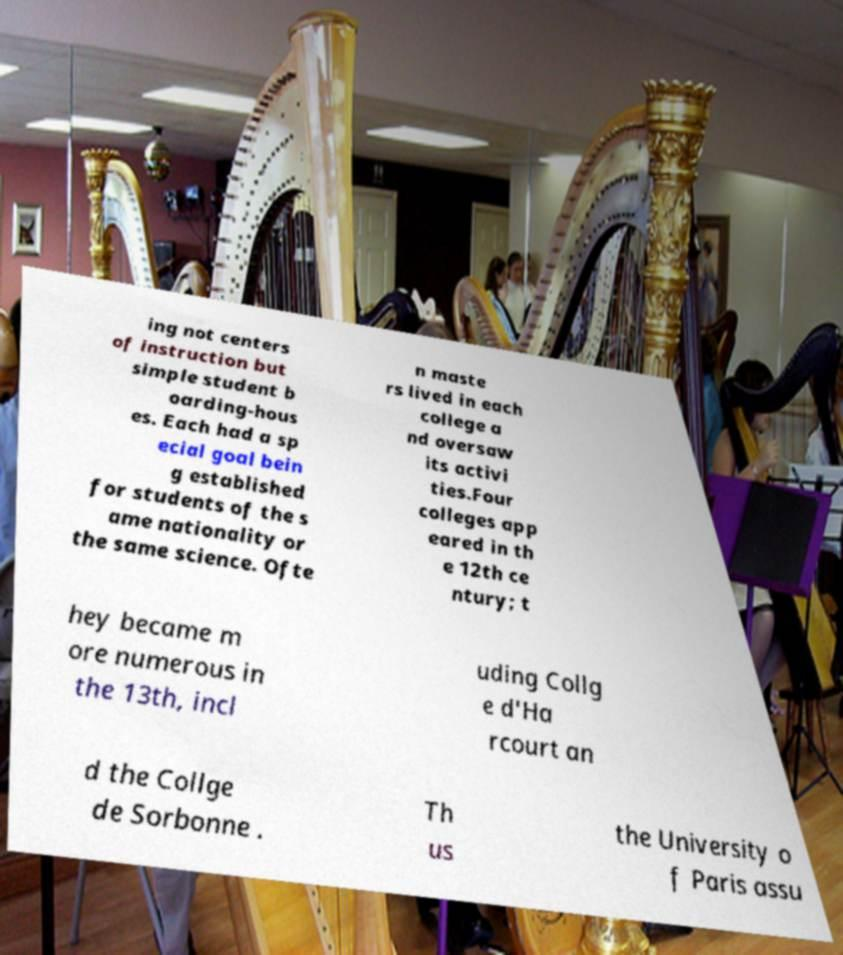Please identify and transcribe the text found in this image. ing not centers of instruction but simple student b oarding-hous es. Each had a sp ecial goal bein g established for students of the s ame nationality or the same science. Ofte n maste rs lived in each college a nd oversaw its activi ties.Four colleges app eared in th e 12th ce ntury; t hey became m ore numerous in the 13th, incl uding Collg e d'Ha rcourt an d the Collge de Sorbonne . Th us the University o f Paris assu 